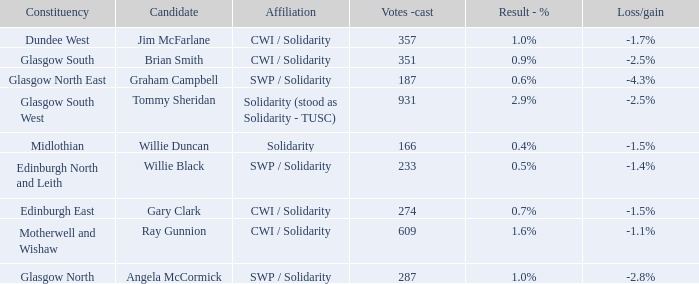What was the loss/gain when the affiliation was solidarity? -1.5%. 